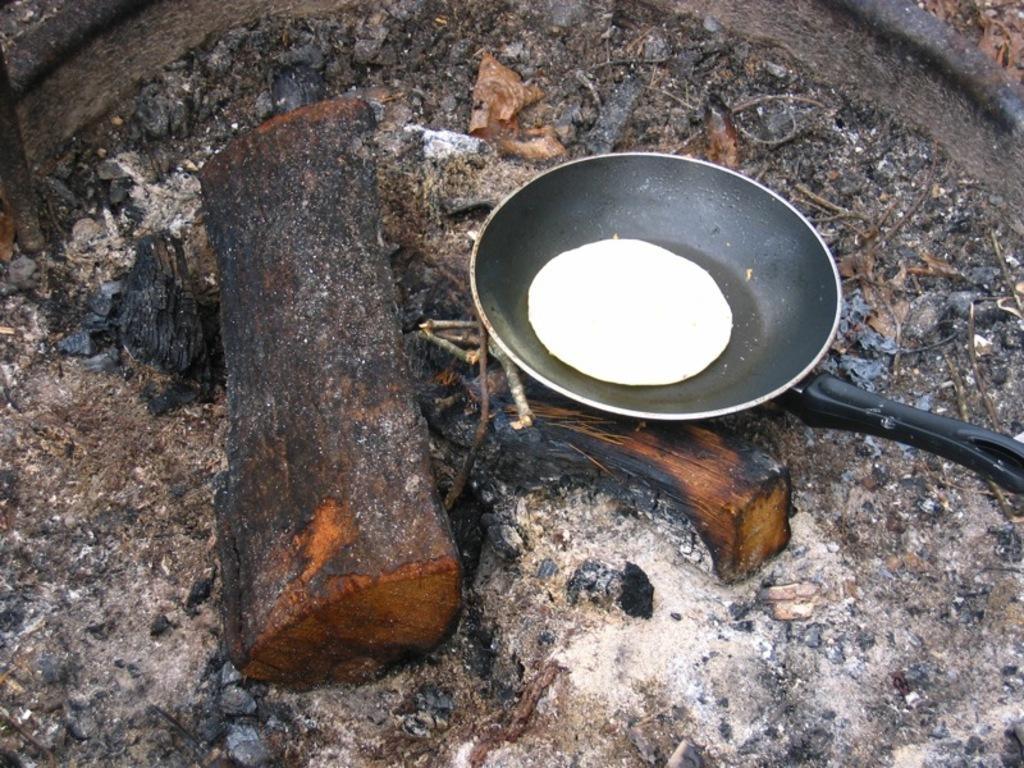Can you describe this image briefly? In this picture we can see a pan with food item in it, wooden logs, sticks and these all are placed on the ground. 